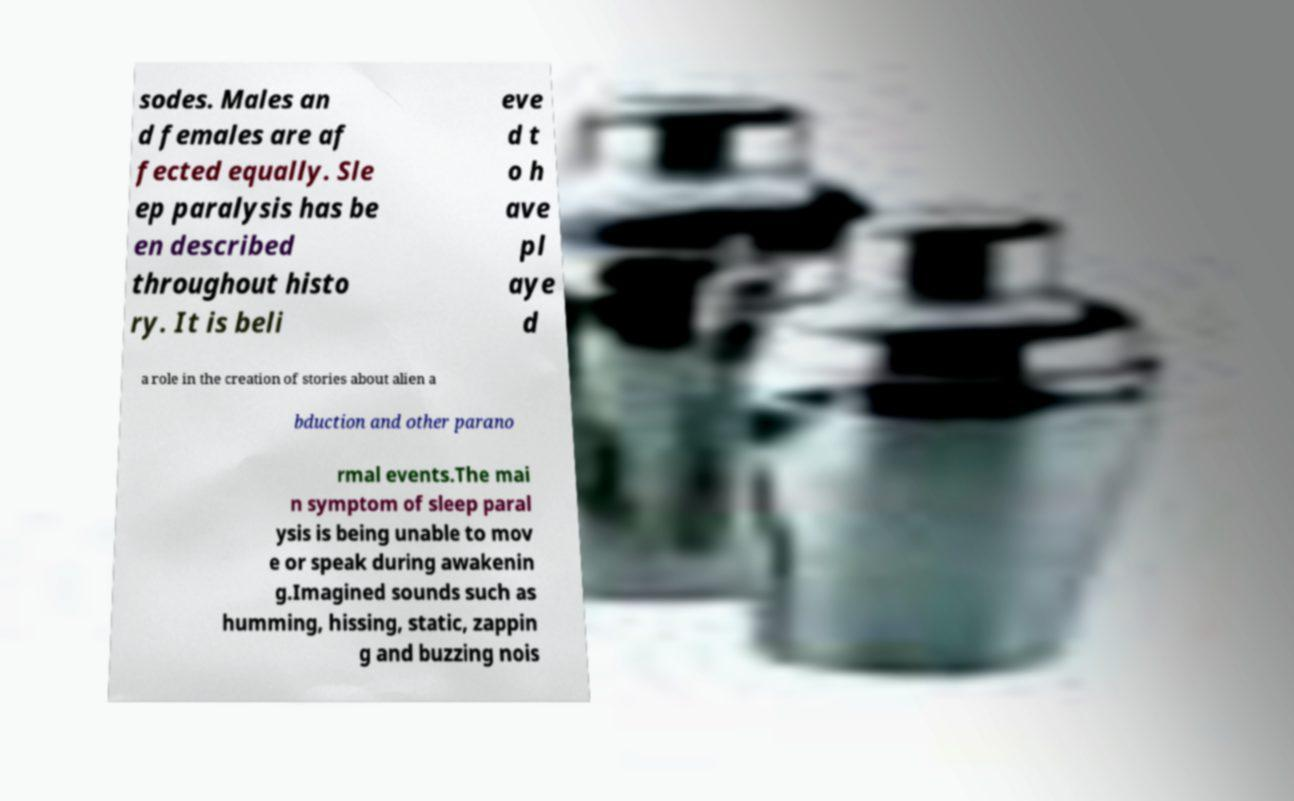Could you extract and type out the text from this image? sodes. Males an d females are af fected equally. Sle ep paralysis has be en described throughout histo ry. It is beli eve d t o h ave pl aye d a role in the creation of stories about alien a bduction and other parano rmal events.The mai n symptom of sleep paral ysis is being unable to mov e or speak during awakenin g.Imagined sounds such as humming, hissing, static, zappin g and buzzing nois 